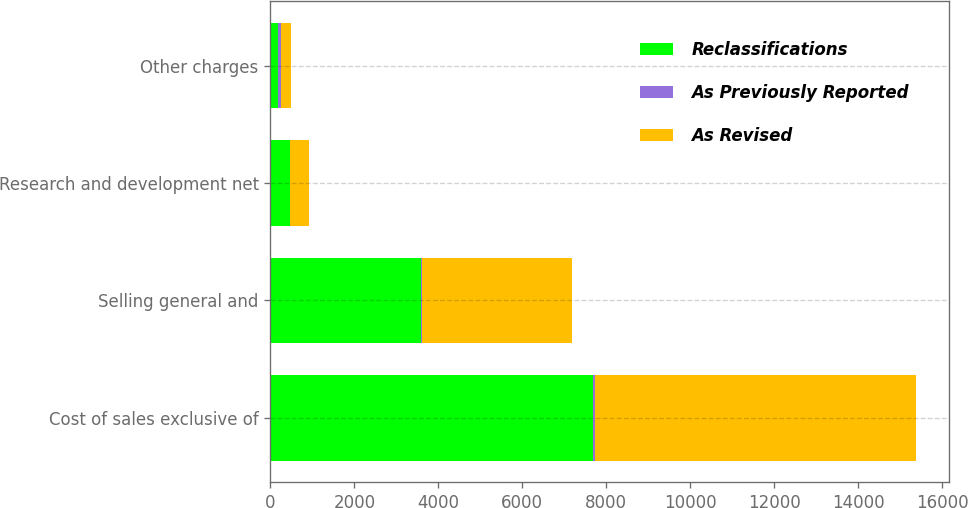Convert chart to OTSL. <chart><loc_0><loc_0><loc_500><loc_500><stacked_bar_chart><ecel><fcel>Cost of sales exclusive of<fcel>Selling general and<fcel>Research and development net<fcel>Other charges<nl><fcel>Reclassifications<fcel>7693<fcel>3588<fcel>459<fcel>175<nl><fcel>As Previously Reported<fcel>28<fcel>33<fcel>6<fcel>67<nl><fcel>As Revised<fcel>7665<fcel>3555<fcel>453<fcel>242<nl></chart> 